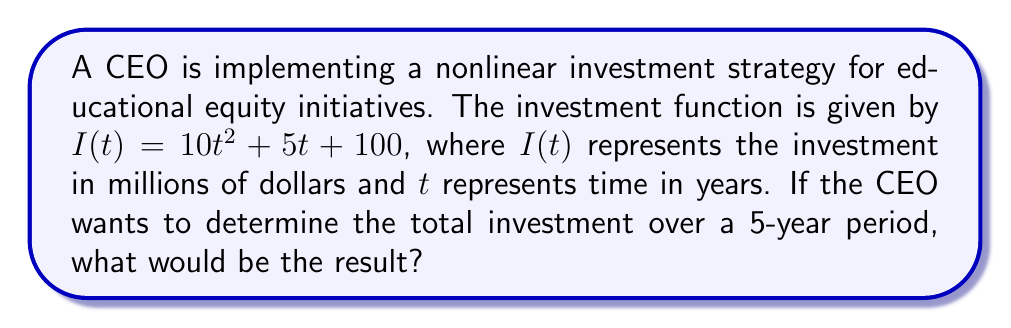Give your solution to this math problem. To solve this problem, we need to calculate the definite integral of the investment function over the given time period. Here's the step-by-step solution:

1) The investment function is $I(t) = 10t^2 + 5t + 100$

2) To find the total investment over 5 years, we need to integrate this function from $t=0$ to $t=5$:

   $$\int_0^5 (10t^2 + 5t + 100) dt$$

3) Let's integrate each term separately:

   $$\int_0^5 10t^2 dt + \int_0^5 5t dt + \int_0^5 100 dt$$

4) Integrating each term:
   
   $$\left[\frac{10t^3}{3}\right]_0^5 + \left[\frac{5t^2}{2}\right]_0^5 + [100t]_0^5$$

5) Evaluating at the limits:

   $$\left(\frac{10(5^3)}{3} - \frac{10(0^3)}{3}\right) + \left(\frac{5(5^2)}{2} - \frac{5(0^2)}{2}\right) + (100(5) - 100(0))$$

6) Simplifying:

   $$\frac{1250}{3} + \frac{125}{2} + 500$$

7) Converting to decimals and adding:

   $$416.67 + 62.5 + 500 = 979.17$$

Therefore, the total investment over the 5-year period would be approximately $979.17 million.
Answer: $979.17 million 